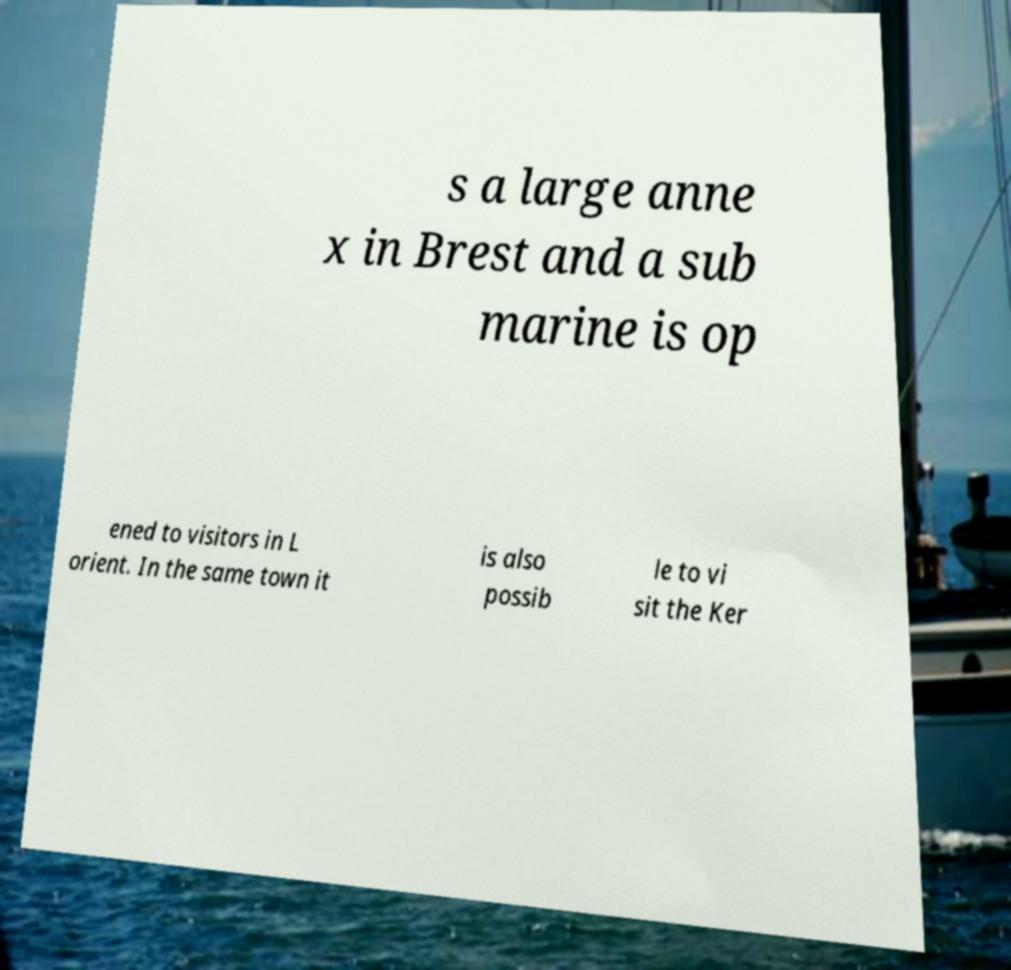Could you assist in decoding the text presented in this image and type it out clearly? s a large anne x in Brest and a sub marine is op ened to visitors in L orient. In the same town it is also possib le to vi sit the Ker 